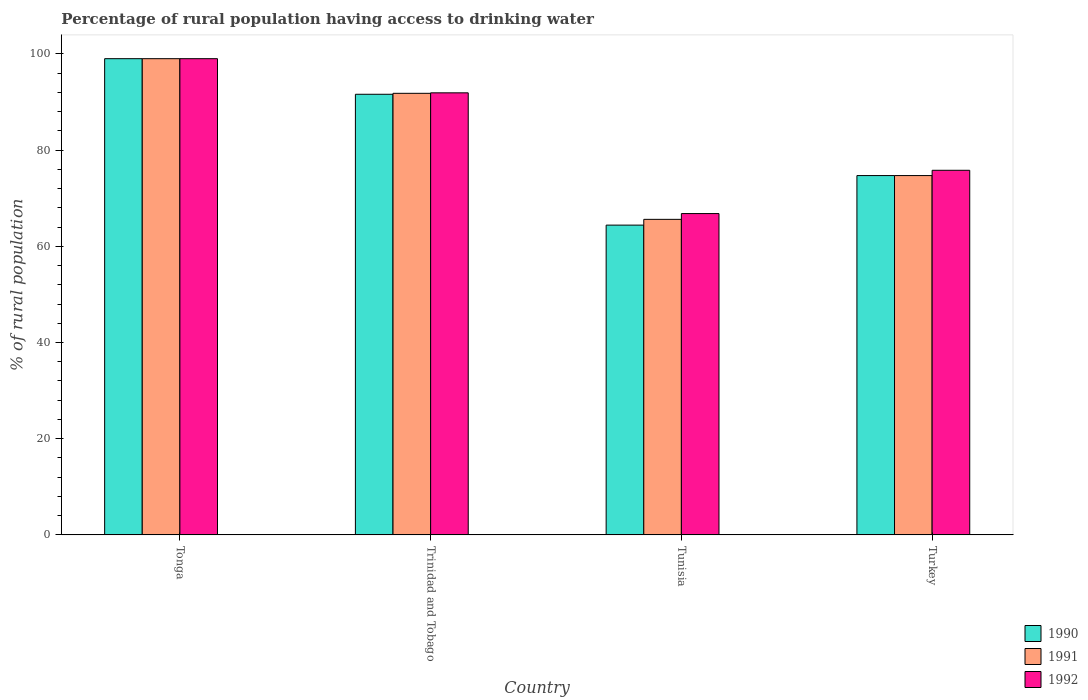How many different coloured bars are there?
Your answer should be very brief. 3. Are the number of bars per tick equal to the number of legend labels?
Make the answer very short. Yes. How many bars are there on the 3rd tick from the left?
Your answer should be compact. 3. How many bars are there on the 1st tick from the right?
Keep it short and to the point. 3. What is the label of the 1st group of bars from the left?
Offer a very short reply. Tonga. What is the percentage of rural population having access to drinking water in 1990 in Tunisia?
Offer a terse response. 64.4. Across all countries, what is the minimum percentage of rural population having access to drinking water in 1992?
Offer a terse response. 66.8. In which country was the percentage of rural population having access to drinking water in 1990 maximum?
Keep it short and to the point. Tonga. In which country was the percentage of rural population having access to drinking water in 1992 minimum?
Your answer should be compact. Tunisia. What is the total percentage of rural population having access to drinking water in 1991 in the graph?
Offer a very short reply. 331.1. What is the difference between the percentage of rural population having access to drinking water in 1992 in Tonga and the percentage of rural population having access to drinking water in 1990 in Turkey?
Ensure brevity in your answer.  24.3. What is the average percentage of rural population having access to drinking water in 1990 per country?
Make the answer very short. 82.42. What is the ratio of the percentage of rural population having access to drinking water in 1990 in Tonga to that in Trinidad and Tobago?
Ensure brevity in your answer.  1.08. Is the difference between the percentage of rural population having access to drinking water in 1990 in Trinidad and Tobago and Turkey greater than the difference between the percentage of rural population having access to drinking water in 1992 in Trinidad and Tobago and Turkey?
Offer a very short reply. Yes. What is the difference between the highest and the second highest percentage of rural population having access to drinking water in 1992?
Ensure brevity in your answer.  -16.1. What is the difference between the highest and the lowest percentage of rural population having access to drinking water in 1992?
Offer a very short reply. 32.2. In how many countries, is the percentage of rural population having access to drinking water in 1990 greater than the average percentage of rural population having access to drinking water in 1990 taken over all countries?
Offer a very short reply. 2. What does the 1st bar from the left in Tonga represents?
Make the answer very short. 1990. What does the 2nd bar from the right in Tunisia represents?
Provide a short and direct response. 1991. Are all the bars in the graph horizontal?
Offer a very short reply. No. How many countries are there in the graph?
Offer a very short reply. 4. What is the difference between two consecutive major ticks on the Y-axis?
Your answer should be very brief. 20. Does the graph contain any zero values?
Your answer should be compact. No. Where does the legend appear in the graph?
Keep it short and to the point. Bottom right. How are the legend labels stacked?
Ensure brevity in your answer.  Vertical. What is the title of the graph?
Your response must be concise. Percentage of rural population having access to drinking water. Does "1972" appear as one of the legend labels in the graph?
Make the answer very short. No. What is the label or title of the X-axis?
Your answer should be very brief. Country. What is the label or title of the Y-axis?
Keep it short and to the point. % of rural population. What is the % of rural population of 1992 in Tonga?
Give a very brief answer. 99. What is the % of rural population in 1990 in Trinidad and Tobago?
Make the answer very short. 91.6. What is the % of rural population of 1991 in Trinidad and Tobago?
Make the answer very short. 91.8. What is the % of rural population in 1992 in Trinidad and Tobago?
Ensure brevity in your answer.  91.9. What is the % of rural population in 1990 in Tunisia?
Provide a short and direct response. 64.4. What is the % of rural population of 1991 in Tunisia?
Provide a short and direct response. 65.6. What is the % of rural population in 1992 in Tunisia?
Provide a short and direct response. 66.8. What is the % of rural population of 1990 in Turkey?
Your answer should be very brief. 74.7. What is the % of rural population of 1991 in Turkey?
Your response must be concise. 74.7. What is the % of rural population in 1992 in Turkey?
Offer a terse response. 75.8. Across all countries, what is the maximum % of rural population of 1990?
Your answer should be compact. 99. Across all countries, what is the maximum % of rural population in 1991?
Provide a succinct answer. 99. Across all countries, what is the maximum % of rural population in 1992?
Ensure brevity in your answer.  99. Across all countries, what is the minimum % of rural population in 1990?
Offer a very short reply. 64.4. Across all countries, what is the minimum % of rural population in 1991?
Your response must be concise. 65.6. Across all countries, what is the minimum % of rural population in 1992?
Provide a succinct answer. 66.8. What is the total % of rural population of 1990 in the graph?
Ensure brevity in your answer.  329.7. What is the total % of rural population of 1991 in the graph?
Provide a succinct answer. 331.1. What is the total % of rural population in 1992 in the graph?
Ensure brevity in your answer.  333.5. What is the difference between the % of rural population of 1990 in Tonga and that in Trinidad and Tobago?
Your response must be concise. 7.4. What is the difference between the % of rural population of 1990 in Tonga and that in Tunisia?
Offer a terse response. 34.6. What is the difference between the % of rural population in 1991 in Tonga and that in Tunisia?
Keep it short and to the point. 33.4. What is the difference between the % of rural population in 1992 in Tonga and that in Tunisia?
Your response must be concise. 32.2. What is the difference between the % of rural population in 1990 in Tonga and that in Turkey?
Your answer should be very brief. 24.3. What is the difference between the % of rural population in 1991 in Tonga and that in Turkey?
Give a very brief answer. 24.3. What is the difference between the % of rural population of 1992 in Tonga and that in Turkey?
Provide a short and direct response. 23.2. What is the difference between the % of rural population of 1990 in Trinidad and Tobago and that in Tunisia?
Provide a short and direct response. 27.2. What is the difference between the % of rural population of 1991 in Trinidad and Tobago and that in Tunisia?
Offer a very short reply. 26.2. What is the difference between the % of rural population of 1992 in Trinidad and Tobago and that in Tunisia?
Offer a very short reply. 25.1. What is the difference between the % of rural population of 1990 in Trinidad and Tobago and that in Turkey?
Your answer should be compact. 16.9. What is the difference between the % of rural population of 1991 in Trinidad and Tobago and that in Turkey?
Provide a short and direct response. 17.1. What is the difference between the % of rural population of 1992 in Trinidad and Tobago and that in Turkey?
Provide a short and direct response. 16.1. What is the difference between the % of rural population in 1990 in Tunisia and that in Turkey?
Make the answer very short. -10.3. What is the difference between the % of rural population in 1992 in Tunisia and that in Turkey?
Offer a terse response. -9. What is the difference between the % of rural population of 1991 in Tonga and the % of rural population of 1992 in Trinidad and Tobago?
Offer a very short reply. 7.1. What is the difference between the % of rural population of 1990 in Tonga and the % of rural population of 1991 in Tunisia?
Keep it short and to the point. 33.4. What is the difference between the % of rural population of 1990 in Tonga and the % of rural population of 1992 in Tunisia?
Your answer should be compact. 32.2. What is the difference between the % of rural population in 1991 in Tonga and the % of rural population in 1992 in Tunisia?
Your answer should be compact. 32.2. What is the difference between the % of rural population of 1990 in Tonga and the % of rural population of 1991 in Turkey?
Offer a terse response. 24.3. What is the difference between the % of rural population in 1990 in Tonga and the % of rural population in 1992 in Turkey?
Give a very brief answer. 23.2. What is the difference between the % of rural population of 1991 in Tonga and the % of rural population of 1992 in Turkey?
Provide a succinct answer. 23.2. What is the difference between the % of rural population of 1990 in Trinidad and Tobago and the % of rural population of 1991 in Tunisia?
Offer a terse response. 26. What is the difference between the % of rural population in 1990 in Trinidad and Tobago and the % of rural population in 1992 in Tunisia?
Offer a terse response. 24.8. What is the difference between the % of rural population in 1991 in Trinidad and Tobago and the % of rural population in 1992 in Turkey?
Your answer should be compact. 16. What is the difference between the % of rural population of 1990 in Tunisia and the % of rural population of 1992 in Turkey?
Offer a very short reply. -11.4. What is the average % of rural population in 1990 per country?
Make the answer very short. 82.42. What is the average % of rural population of 1991 per country?
Your response must be concise. 82.78. What is the average % of rural population of 1992 per country?
Offer a terse response. 83.38. What is the difference between the % of rural population in 1990 and % of rural population in 1991 in Tonga?
Keep it short and to the point. 0. What is the difference between the % of rural population in 1990 and % of rural population in 1992 in Tonga?
Your answer should be very brief. 0. What is the difference between the % of rural population in 1990 and % of rural population in 1991 in Trinidad and Tobago?
Keep it short and to the point. -0.2. What is the difference between the % of rural population of 1990 and % of rural population of 1992 in Trinidad and Tobago?
Ensure brevity in your answer.  -0.3. What is the difference between the % of rural population in 1990 and % of rural population in 1991 in Tunisia?
Offer a terse response. -1.2. What is the difference between the % of rural population of 1990 and % of rural population of 1992 in Tunisia?
Provide a succinct answer. -2.4. What is the difference between the % of rural population of 1991 and % of rural population of 1992 in Tunisia?
Ensure brevity in your answer.  -1.2. What is the difference between the % of rural population of 1991 and % of rural population of 1992 in Turkey?
Provide a succinct answer. -1.1. What is the ratio of the % of rural population of 1990 in Tonga to that in Trinidad and Tobago?
Your answer should be very brief. 1.08. What is the ratio of the % of rural population of 1991 in Tonga to that in Trinidad and Tobago?
Make the answer very short. 1.08. What is the ratio of the % of rural population of 1992 in Tonga to that in Trinidad and Tobago?
Your answer should be very brief. 1.08. What is the ratio of the % of rural population in 1990 in Tonga to that in Tunisia?
Provide a succinct answer. 1.54. What is the ratio of the % of rural population in 1991 in Tonga to that in Tunisia?
Make the answer very short. 1.51. What is the ratio of the % of rural population in 1992 in Tonga to that in Tunisia?
Ensure brevity in your answer.  1.48. What is the ratio of the % of rural population of 1990 in Tonga to that in Turkey?
Give a very brief answer. 1.33. What is the ratio of the % of rural population in 1991 in Tonga to that in Turkey?
Make the answer very short. 1.33. What is the ratio of the % of rural population in 1992 in Tonga to that in Turkey?
Give a very brief answer. 1.31. What is the ratio of the % of rural population of 1990 in Trinidad and Tobago to that in Tunisia?
Your response must be concise. 1.42. What is the ratio of the % of rural population of 1991 in Trinidad and Tobago to that in Tunisia?
Keep it short and to the point. 1.4. What is the ratio of the % of rural population in 1992 in Trinidad and Tobago to that in Tunisia?
Give a very brief answer. 1.38. What is the ratio of the % of rural population of 1990 in Trinidad and Tobago to that in Turkey?
Your response must be concise. 1.23. What is the ratio of the % of rural population of 1991 in Trinidad and Tobago to that in Turkey?
Ensure brevity in your answer.  1.23. What is the ratio of the % of rural population of 1992 in Trinidad and Tobago to that in Turkey?
Your answer should be very brief. 1.21. What is the ratio of the % of rural population in 1990 in Tunisia to that in Turkey?
Provide a short and direct response. 0.86. What is the ratio of the % of rural population in 1991 in Tunisia to that in Turkey?
Your answer should be very brief. 0.88. What is the ratio of the % of rural population in 1992 in Tunisia to that in Turkey?
Provide a succinct answer. 0.88. What is the difference between the highest and the second highest % of rural population in 1990?
Ensure brevity in your answer.  7.4. What is the difference between the highest and the second highest % of rural population of 1992?
Your answer should be very brief. 7.1. What is the difference between the highest and the lowest % of rural population in 1990?
Provide a succinct answer. 34.6. What is the difference between the highest and the lowest % of rural population in 1991?
Offer a very short reply. 33.4. What is the difference between the highest and the lowest % of rural population of 1992?
Make the answer very short. 32.2. 